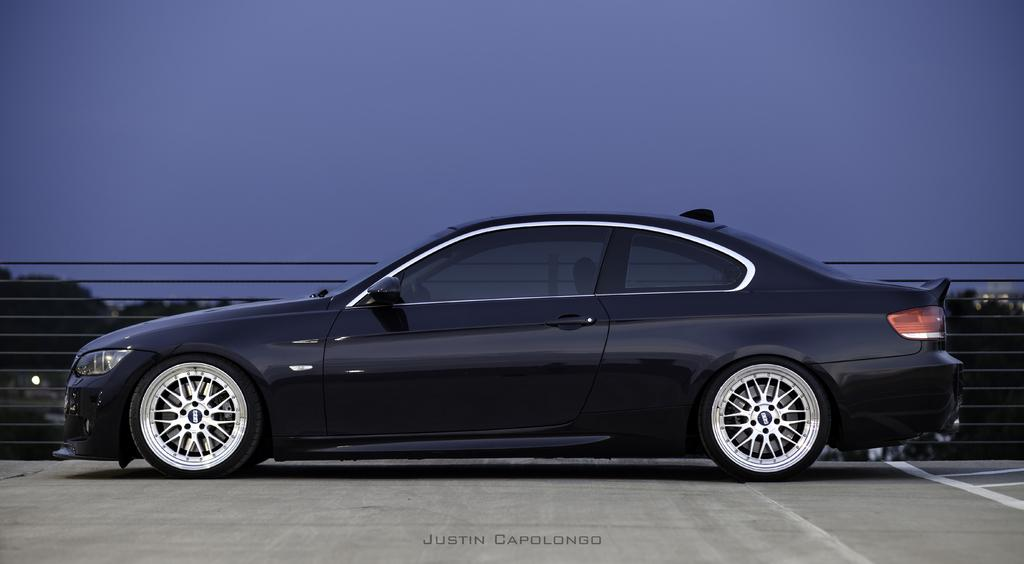What type of vehicle is in the image? There is a black car in the image. What other objects or features can be seen in the image? There are trees and the sky visible in the image. Can you see a tiger hiding behind the trees in the image? There is no tiger present in the image; only a black car, trees, and the sky are visible. 